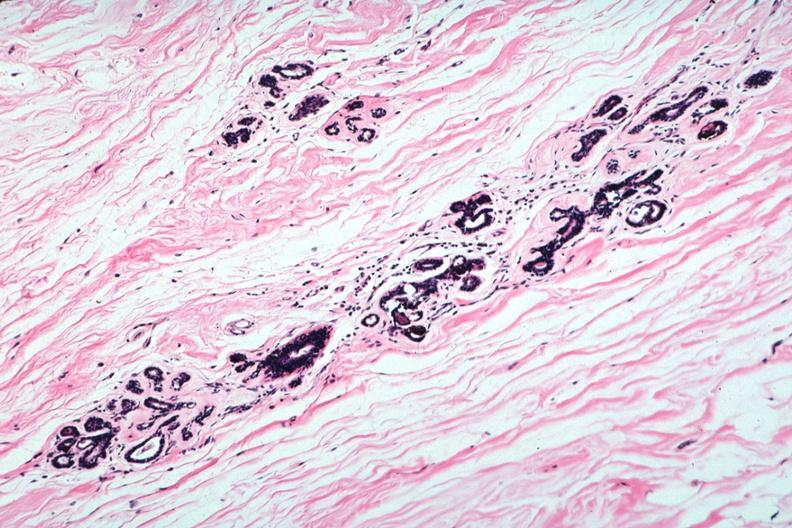does macerated stillborn show atrophic lobules and normal connective tissue?
Answer the question using a single word or phrase. No 